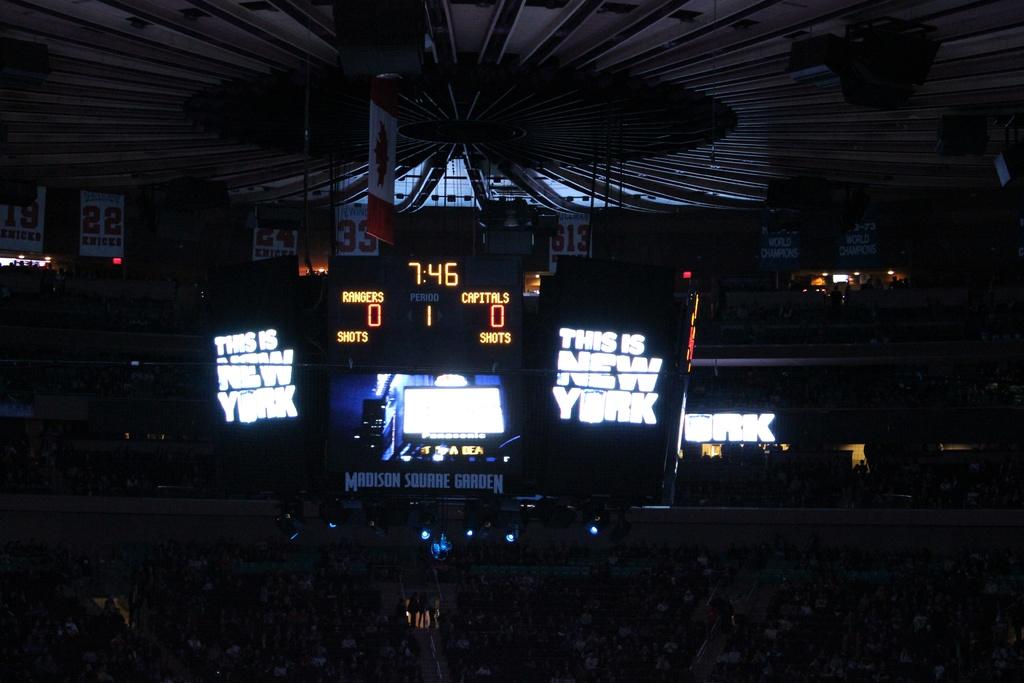What is the time?
Offer a terse response. 7:46. 